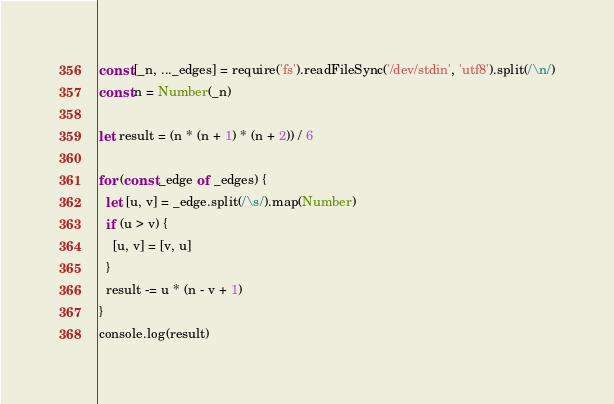Convert code to text. <code><loc_0><loc_0><loc_500><loc_500><_JavaScript_>const [_n, ..._edges] = require('fs').readFileSync('/dev/stdin', 'utf8').split(/\n/)
const n = Number(_n)

let result = (n * (n + 1) * (n + 2)) / 6

for (const _edge of _edges) {
  let [u, v] = _edge.split(/\s/).map(Number)
  if (u > v) {
    [u, v] = [v, u]
  }
  result -= u * (n - v + 1)
}
console.log(result)</code> 